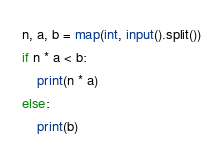<code> <loc_0><loc_0><loc_500><loc_500><_Python_>n, a, b = map(int, input().split())
if n * a < b:
	print(n * a)
else:
	print(b)</code> 